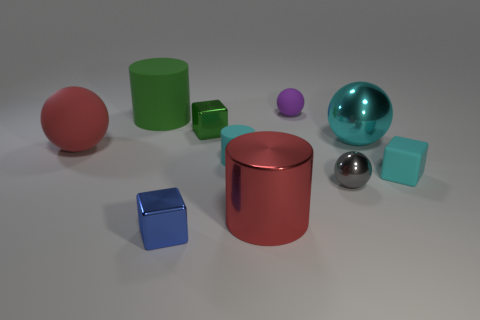Is the number of small blue metal objects that are right of the tiny purple sphere less than the number of large cyan spheres left of the red cylinder? After carefully examining the image, it appears that there is only one small blue metal object, a cube, located to the right of the tiny purple sphere. On the other hand, there are no large cyan spheres to the left of the red cylinder. Therefore, the answer to the question is yes; the number of small blue metal objects right of the tiny purple sphere is indeed less than the number of large cyan spheres left of the red cylinder, as the latter count is zero. 